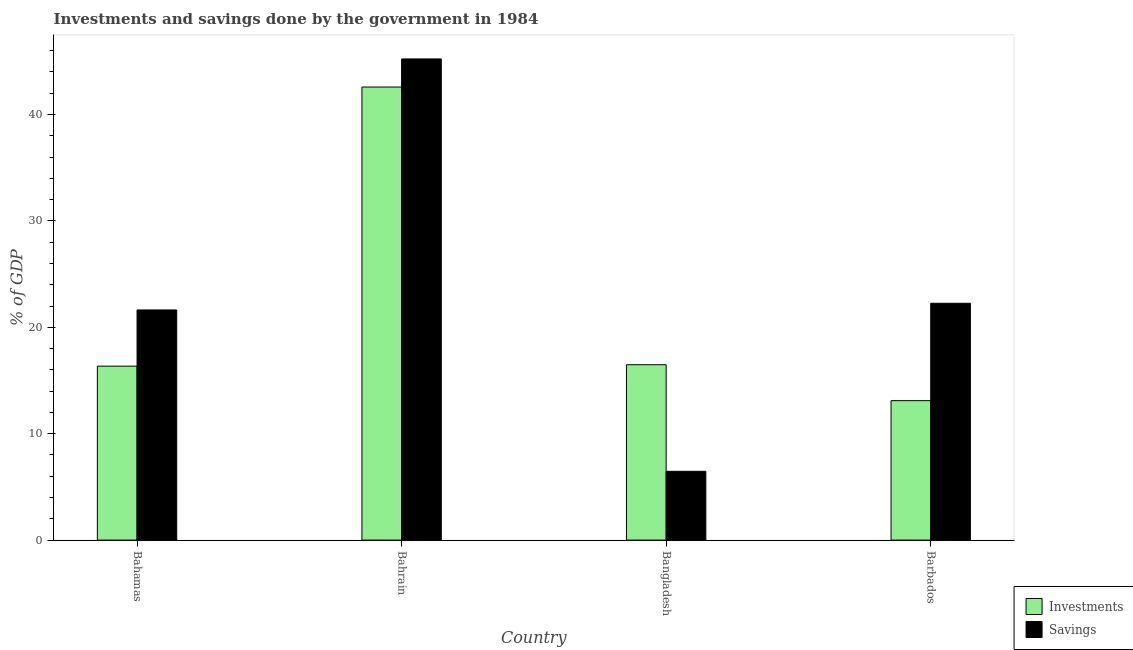How many different coloured bars are there?
Ensure brevity in your answer.  2. Are the number of bars on each tick of the X-axis equal?
Make the answer very short. Yes. What is the label of the 3rd group of bars from the left?
Ensure brevity in your answer.  Bangladesh. What is the investments of government in Bahrain?
Offer a terse response. 42.58. Across all countries, what is the maximum investments of government?
Give a very brief answer. 42.58. Across all countries, what is the minimum investments of government?
Offer a terse response. 13.1. In which country was the savings of government maximum?
Your response must be concise. Bahrain. In which country was the investments of government minimum?
Offer a very short reply. Barbados. What is the total savings of government in the graph?
Provide a short and direct response. 95.58. What is the difference between the savings of government in Bangladesh and that in Barbados?
Make the answer very short. -15.79. What is the difference between the investments of government in Bangladesh and the savings of government in Bahrain?
Give a very brief answer. -28.74. What is the average savings of government per country?
Give a very brief answer. 23.89. What is the difference between the investments of government and savings of government in Barbados?
Give a very brief answer. -9.15. In how many countries, is the investments of government greater than 44 %?
Your answer should be compact. 0. What is the ratio of the savings of government in Bahamas to that in Bangladesh?
Ensure brevity in your answer.  3.35. Is the investments of government in Bahamas less than that in Bangladesh?
Give a very brief answer. Yes. What is the difference between the highest and the second highest investments of government?
Give a very brief answer. 26.1. What is the difference between the highest and the lowest savings of government?
Make the answer very short. 38.76. In how many countries, is the savings of government greater than the average savings of government taken over all countries?
Your response must be concise. 1. Is the sum of the investments of government in Bangladesh and Barbados greater than the maximum savings of government across all countries?
Keep it short and to the point. No. What does the 1st bar from the left in Bahrain represents?
Your answer should be compact. Investments. What does the 2nd bar from the right in Bahamas represents?
Offer a very short reply. Investments. How many countries are there in the graph?
Keep it short and to the point. 4. What is the difference between two consecutive major ticks on the Y-axis?
Make the answer very short. 10. Does the graph contain any zero values?
Offer a terse response. No. Does the graph contain grids?
Provide a succinct answer. No. What is the title of the graph?
Ensure brevity in your answer.  Investments and savings done by the government in 1984. Does "Education" appear as one of the legend labels in the graph?
Provide a succinct answer. No. What is the label or title of the Y-axis?
Keep it short and to the point. % of GDP. What is the % of GDP in Investments in Bahamas?
Your answer should be very brief. 16.35. What is the % of GDP of Savings in Bahamas?
Provide a succinct answer. 21.63. What is the % of GDP in Investments in Bahrain?
Offer a terse response. 42.58. What is the % of GDP in Savings in Bahrain?
Give a very brief answer. 45.22. What is the % of GDP in Investments in Bangladesh?
Offer a terse response. 16.48. What is the % of GDP of Savings in Bangladesh?
Provide a short and direct response. 6.47. What is the % of GDP of Investments in Barbados?
Your answer should be compact. 13.1. What is the % of GDP in Savings in Barbados?
Make the answer very short. 22.26. Across all countries, what is the maximum % of GDP of Investments?
Offer a very short reply. 42.58. Across all countries, what is the maximum % of GDP in Savings?
Your answer should be very brief. 45.22. Across all countries, what is the minimum % of GDP in Investments?
Your answer should be compact. 13.1. Across all countries, what is the minimum % of GDP of Savings?
Provide a short and direct response. 6.47. What is the total % of GDP in Investments in the graph?
Your response must be concise. 88.52. What is the total % of GDP in Savings in the graph?
Your response must be concise. 95.58. What is the difference between the % of GDP of Investments in Bahamas and that in Bahrain?
Your answer should be very brief. -26.23. What is the difference between the % of GDP of Savings in Bahamas and that in Bahrain?
Make the answer very short. -23.59. What is the difference between the % of GDP of Investments in Bahamas and that in Bangladesh?
Offer a terse response. -0.14. What is the difference between the % of GDP of Savings in Bahamas and that in Bangladesh?
Ensure brevity in your answer.  15.17. What is the difference between the % of GDP of Investments in Bahamas and that in Barbados?
Give a very brief answer. 3.24. What is the difference between the % of GDP in Savings in Bahamas and that in Barbados?
Provide a short and direct response. -0.63. What is the difference between the % of GDP in Investments in Bahrain and that in Bangladesh?
Give a very brief answer. 26.1. What is the difference between the % of GDP in Savings in Bahrain and that in Bangladesh?
Offer a terse response. 38.76. What is the difference between the % of GDP of Investments in Bahrain and that in Barbados?
Your response must be concise. 29.48. What is the difference between the % of GDP of Savings in Bahrain and that in Barbados?
Provide a short and direct response. 22.96. What is the difference between the % of GDP in Investments in Bangladesh and that in Barbados?
Your response must be concise. 3.38. What is the difference between the % of GDP of Savings in Bangladesh and that in Barbados?
Ensure brevity in your answer.  -15.79. What is the difference between the % of GDP in Investments in Bahamas and the % of GDP in Savings in Bahrain?
Your answer should be compact. -28.87. What is the difference between the % of GDP in Investments in Bahamas and the % of GDP in Savings in Bangladesh?
Ensure brevity in your answer.  9.88. What is the difference between the % of GDP of Investments in Bahamas and the % of GDP of Savings in Barbados?
Give a very brief answer. -5.91. What is the difference between the % of GDP in Investments in Bahrain and the % of GDP in Savings in Bangladesh?
Your answer should be very brief. 36.12. What is the difference between the % of GDP in Investments in Bahrain and the % of GDP in Savings in Barbados?
Ensure brevity in your answer.  20.32. What is the difference between the % of GDP of Investments in Bangladesh and the % of GDP of Savings in Barbados?
Keep it short and to the point. -5.77. What is the average % of GDP of Investments per country?
Your answer should be compact. 22.13. What is the average % of GDP of Savings per country?
Ensure brevity in your answer.  23.89. What is the difference between the % of GDP in Investments and % of GDP in Savings in Bahamas?
Your answer should be compact. -5.28. What is the difference between the % of GDP of Investments and % of GDP of Savings in Bahrain?
Keep it short and to the point. -2.64. What is the difference between the % of GDP in Investments and % of GDP in Savings in Bangladesh?
Your answer should be compact. 10.02. What is the difference between the % of GDP of Investments and % of GDP of Savings in Barbados?
Your response must be concise. -9.15. What is the ratio of the % of GDP in Investments in Bahamas to that in Bahrain?
Your answer should be compact. 0.38. What is the ratio of the % of GDP in Savings in Bahamas to that in Bahrain?
Ensure brevity in your answer.  0.48. What is the ratio of the % of GDP in Investments in Bahamas to that in Bangladesh?
Your answer should be very brief. 0.99. What is the ratio of the % of GDP in Savings in Bahamas to that in Bangladesh?
Your answer should be compact. 3.35. What is the ratio of the % of GDP in Investments in Bahamas to that in Barbados?
Provide a succinct answer. 1.25. What is the ratio of the % of GDP of Savings in Bahamas to that in Barbados?
Give a very brief answer. 0.97. What is the ratio of the % of GDP of Investments in Bahrain to that in Bangladesh?
Provide a short and direct response. 2.58. What is the ratio of the % of GDP of Savings in Bahrain to that in Bangladesh?
Ensure brevity in your answer.  7. What is the ratio of the % of GDP of Investments in Bahrain to that in Barbados?
Keep it short and to the point. 3.25. What is the ratio of the % of GDP of Savings in Bahrain to that in Barbados?
Keep it short and to the point. 2.03. What is the ratio of the % of GDP in Investments in Bangladesh to that in Barbados?
Provide a succinct answer. 1.26. What is the ratio of the % of GDP of Savings in Bangladesh to that in Barbados?
Make the answer very short. 0.29. What is the difference between the highest and the second highest % of GDP of Investments?
Provide a short and direct response. 26.1. What is the difference between the highest and the second highest % of GDP of Savings?
Keep it short and to the point. 22.96. What is the difference between the highest and the lowest % of GDP of Investments?
Your answer should be compact. 29.48. What is the difference between the highest and the lowest % of GDP of Savings?
Your answer should be very brief. 38.76. 